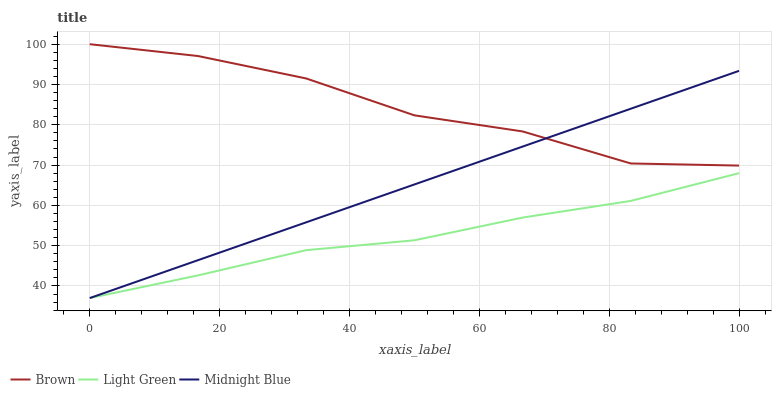Does Light Green have the minimum area under the curve?
Answer yes or no. Yes. Does Brown have the maximum area under the curve?
Answer yes or no. Yes. Does Midnight Blue have the minimum area under the curve?
Answer yes or no. No. Does Midnight Blue have the maximum area under the curve?
Answer yes or no. No. Is Midnight Blue the smoothest?
Answer yes or no. Yes. Is Brown the roughest?
Answer yes or no. Yes. Is Light Green the smoothest?
Answer yes or no. No. Is Light Green the roughest?
Answer yes or no. No. Does Midnight Blue have the lowest value?
Answer yes or no. Yes. Does Brown have the highest value?
Answer yes or no. Yes. Does Midnight Blue have the highest value?
Answer yes or no. No. Is Light Green less than Brown?
Answer yes or no. Yes. Is Brown greater than Light Green?
Answer yes or no. Yes. Does Brown intersect Midnight Blue?
Answer yes or no. Yes. Is Brown less than Midnight Blue?
Answer yes or no. No. Is Brown greater than Midnight Blue?
Answer yes or no. No. Does Light Green intersect Brown?
Answer yes or no. No. 